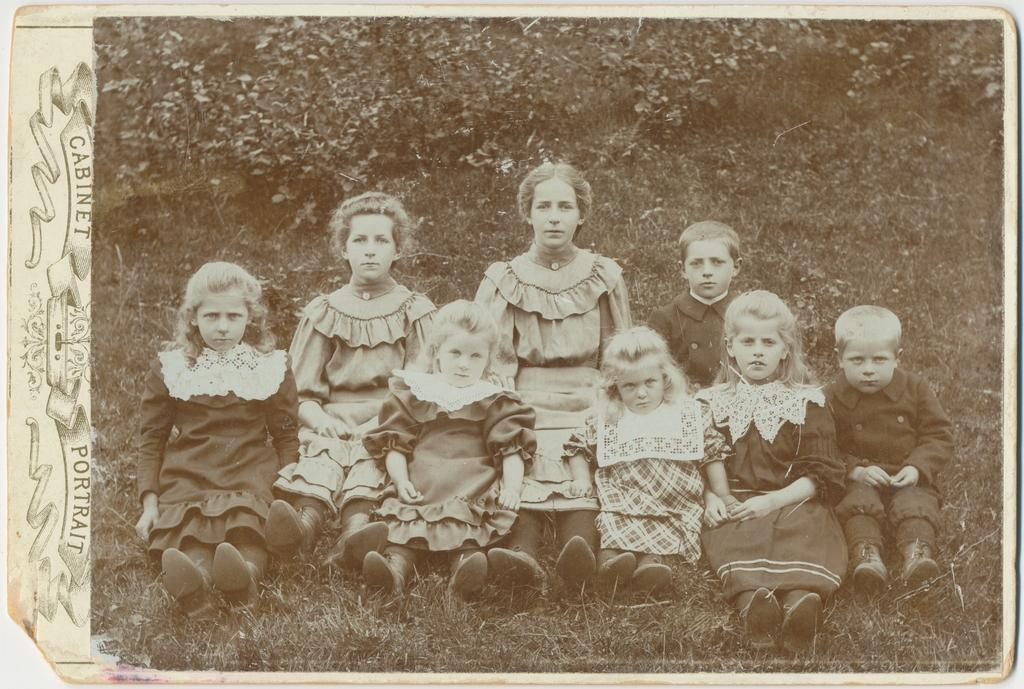What is the main subject of the image? The main subject of the image is a photo. What are the kids doing in the image? The kids are sitting on the grassland in the image. What can be seen near the kids? There are plants near the kids in the image. What is present on the left side of the image? There is some text on the left side of the image. What type of haircut does the kid on the right have in the image? There is no kid on the right in the image, and therefore no haircut can be observed. What is the kid writing on the grassland in the image? There is no kid writing on the grassland in the image; the kids are simply sitting on the grass. 